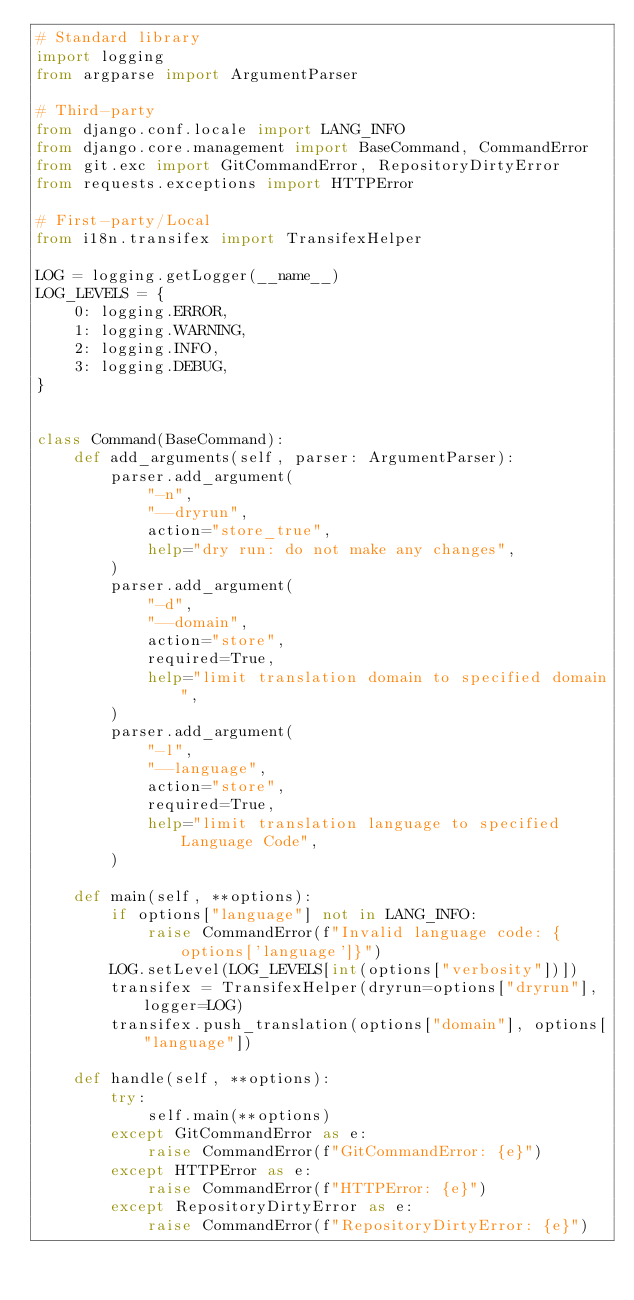Convert code to text. <code><loc_0><loc_0><loc_500><loc_500><_Python_># Standard library
import logging
from argparse import ArgumentParser

# Third-party
from django.conf.locale import LANG_INFO
from django.core.management import BaseCommand, CommandError
from git.exc import GitCommandError, RepositoryDirtyError
from requests.exceptions import HTTPError

# First-party/Local
from i18n.transifex import TransifexHelper

LOG = logging.getLogger(__name__)
LOG_LEVELS = {
    0: logging.ERROR,
    1: logging.WARNING,
    2: logging.INFO,
    3: logging.DEBUG,
}


class Command(BaseCommand):
    def add_arguments(self, parser: ArgumentParser):
        parser.add_argument(
            "-n",
            "--dryrun",
            action="store_true",
            help="dry run: do not make any changes",
        )
        parser.add_argument(
            "-d",
            "--domain",
            action="store",
            required=True,
            help="limit translation domain to specified domain",
        )
        parser.add_argument(
            "-l",
            "--language",
            action="store",
            required=True,
            help="limit translation language to specified Language Code",
        )

    def main(self, **options):
        if options["language"] not in LANG_INFO:
            raise CommandError(f"Invalid language code: {options['language']}")
        LOG.setLevel(LOG_LEVELS[int(options["verbosity"])])
        transifex = TransifexHelper(dryrun=options["dryrun"], logger=LOG)
        transifex.push_translation(options["domain"], options["language"])

    def handle(self, **options):
        try:
            self.main(**options)
        except GitCommandError as e:
            raise CommandError(f"GitCommandError: {e}")
        except HTTPError as e:
            raise CommandError(f"HTTPError: {e}")
        except RepositoryDirtyError as e:
            raise CommandError(f"RepositoryDirtyError: {e}")
</code> 